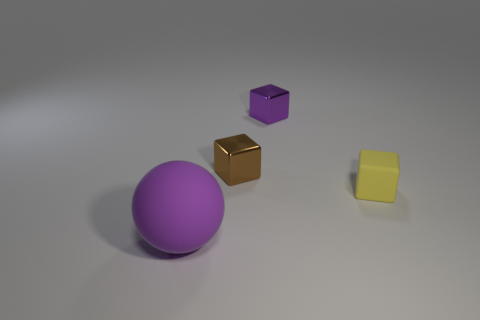Add 3 yellow things. How many objects exist? 7 Subtract all cubes. How many objects are left? 1 Subtract 0 green cylinders. How many objects are left? 4 Subtract all large red shiny objects. Subtract all big rubber spheres. How many objects are left? 3 Add 3 tiny blocks. How many tiny blocks are left? 6 Add 3 purple metal objects. How many purple metal objects exist? 4 